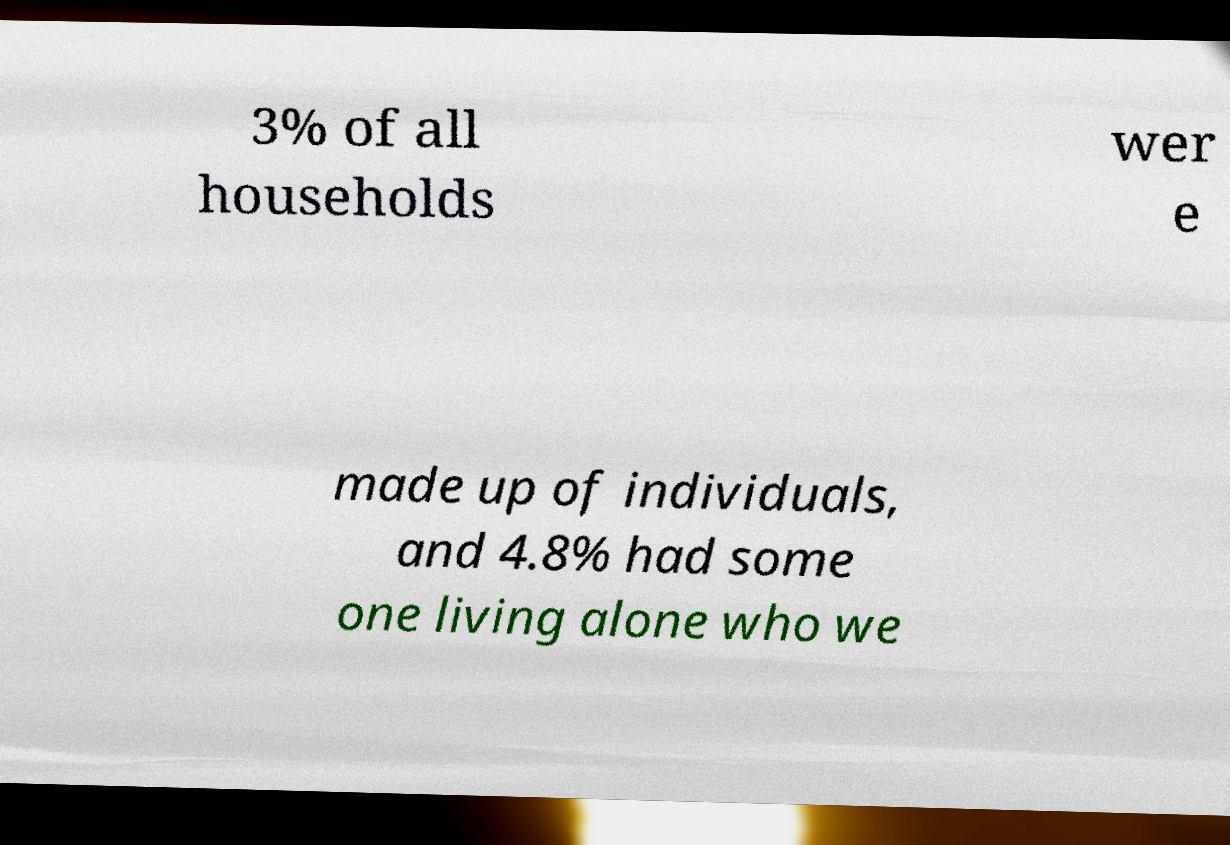There's text embedded in this image that I need extracted. Can you transcribe it verbatim? 3% of all households wer e made up of individuals, and 4.8% had some one living alone who we 